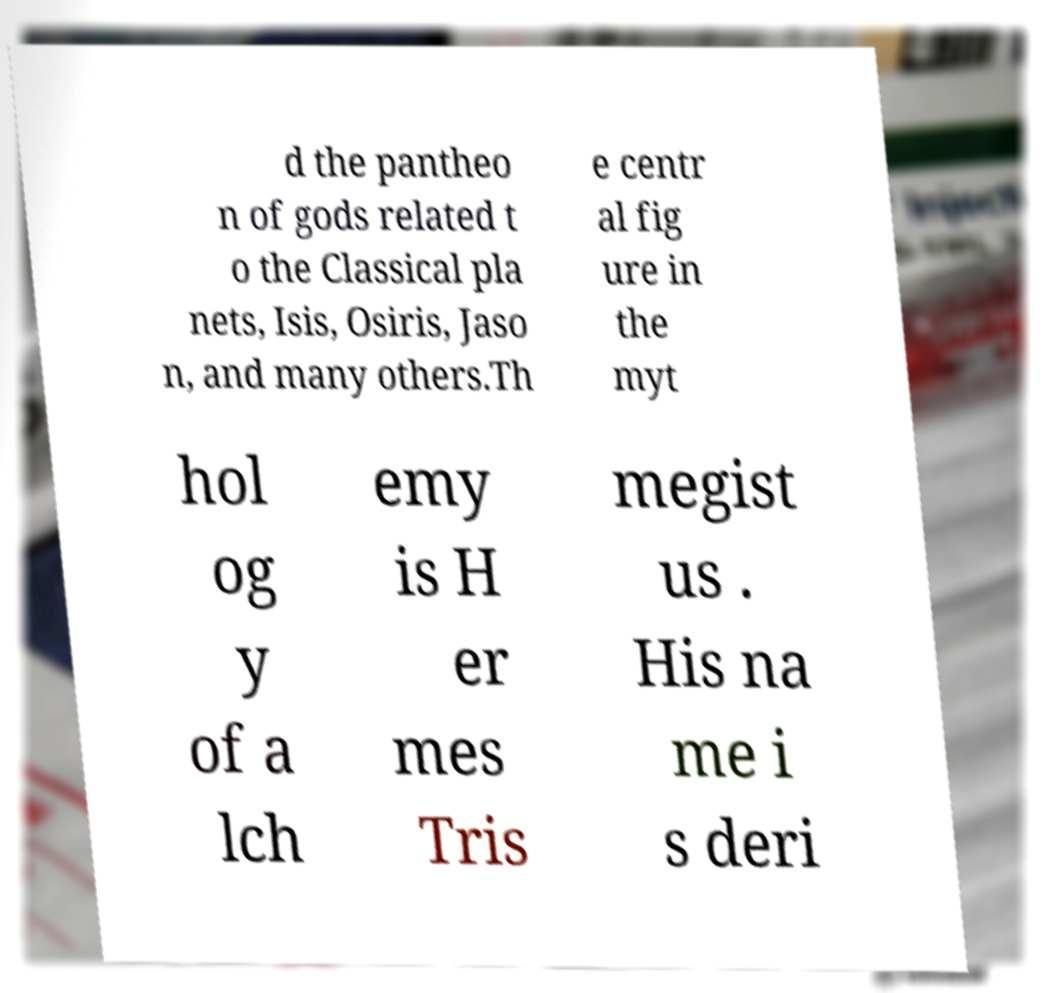Please identify and transcribe the text found in this image. d the pantheo n of gods related t o the Classical pla nets, Isis, Osiris, Jaso n, and many others.Th e centr al fig ure in the myt hol og y of a lch emy is H er mes Tris megist us . His na me i s deri 